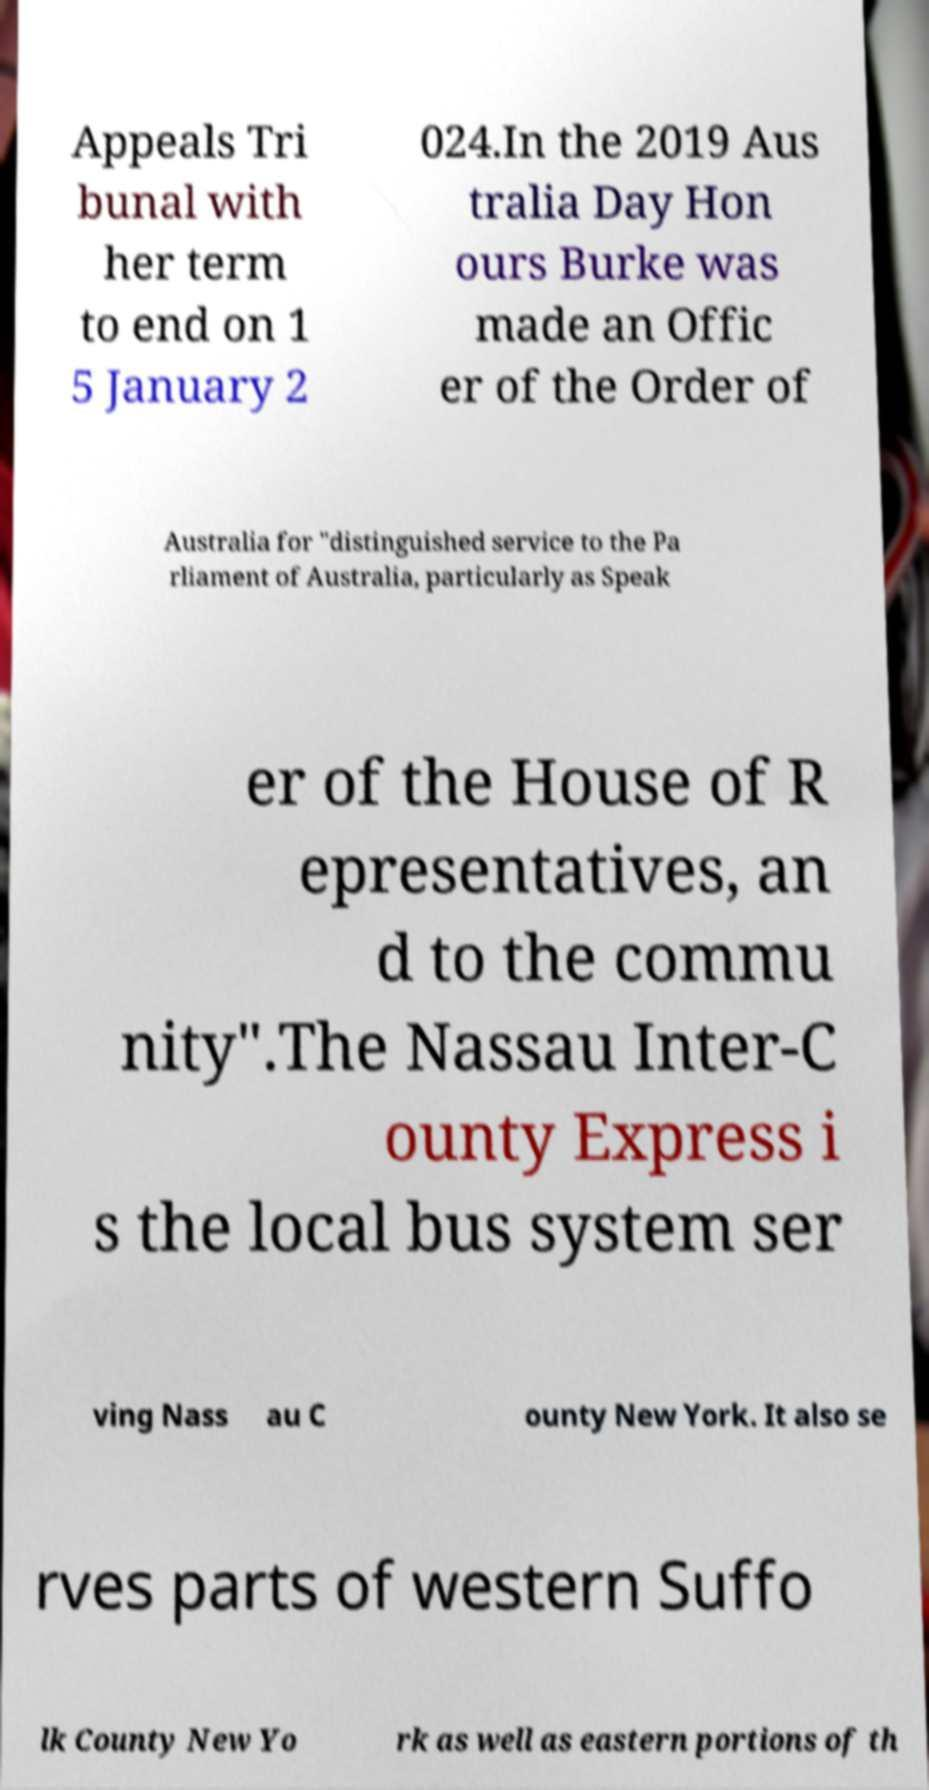Can you read and provide the text displayed in the image?This photo seems to have some interesting text. Can you extract and type it out for me? Appeals Tri bunal with her term to end on 1 5 January 2 024.In the 2019 Aus tralia Day Hon ours Burke was made an Offic er of the Order of Australia for "distinguished service to the Pa rliament of Australia, particularly as Speak er of the House of R epresentatives, an d to the commu nity".The Nassau Inter-C ounty Express i s the local bus system ser ving Nass au C ounty New York. It also se rves parts of western Suffo lk County New Yo rk as well as eastern portions of th 